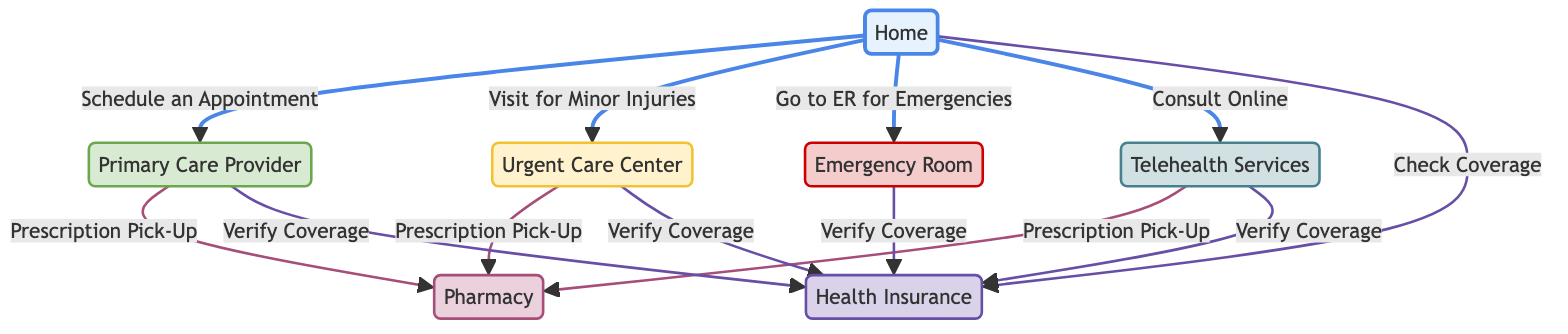What's the total number of nodes in the diagram? The diagram includes seven distinct nodes: Home, Primary Care Provider, Urgent Care Center, Emergency Room, Telehealth Services, Pharmacy, and Health Insurance. Thus, the total count is seven.
Answer: 7 What service should you visit for minor injuries? According to the edge direction from Home, the designated service for minor injuries is Urgent Care Center, which is explicitly labeled in the diagram.
Answer: Urgent Care Center How can you consult with a healthcare provider from home? The diagram specifies that you can Consult Online through the Telehealth Services node, which is directly linked from Home.
Answer: Telehealth Services What are the pathways from the Emergency Room to verify insurance coverage? The path to verify insurance coverage from the Emergency Room is to follow the edge that leads from Emergency Room to Health Insurance, which states "Verify Coverage."
Answer: Verify Coverage Which nodes can you access from your Home? The diagram shows four direct pathways from Home: Schedule an Appointment to Primary Care Provider, Visit for Minor Injuries to Urgent Care Center, Go to ER for Emergencies to Emergency Room, and Consult Online to Telehealth. Therefore, four nodes can be accessed directly from Home.
Answer: Primary Care Provider, Urgent Care Center, Emergency Room, Telehealth Services What is the relationship between Urgent Care Center and Pharmacy? The diagram clearly indicates that there is a directed edge from Urgent Care Center to Pharmacy, labeled "Prescription Pick-Up," showing that one can pick up prescriptions after visiting the Urgent Care Center.
Answer: Prescription Pick-Up Which health service requires you to check coverage from Home? The edge leading from Home to Health Insurance is linked under "Check Coverage," which indicates that you should verify your coverage before accessing health services.
Answer: Check Coverage How many nodes require verifying health insurance coverage? There are four nodes connected to Health Insurance for verifying coverage: Primary Care Provider, Urgent Care Center, Emergency Room, and Telehealth, meaning the answer is four.
Answer: 4 What service is depicted as an alternative consultation method in the diagram? The diagram provides Telehealth Services as an alternative method of consultation, indicated by the direct connection from Home for online consultation.
Answer: Telehealth Services 